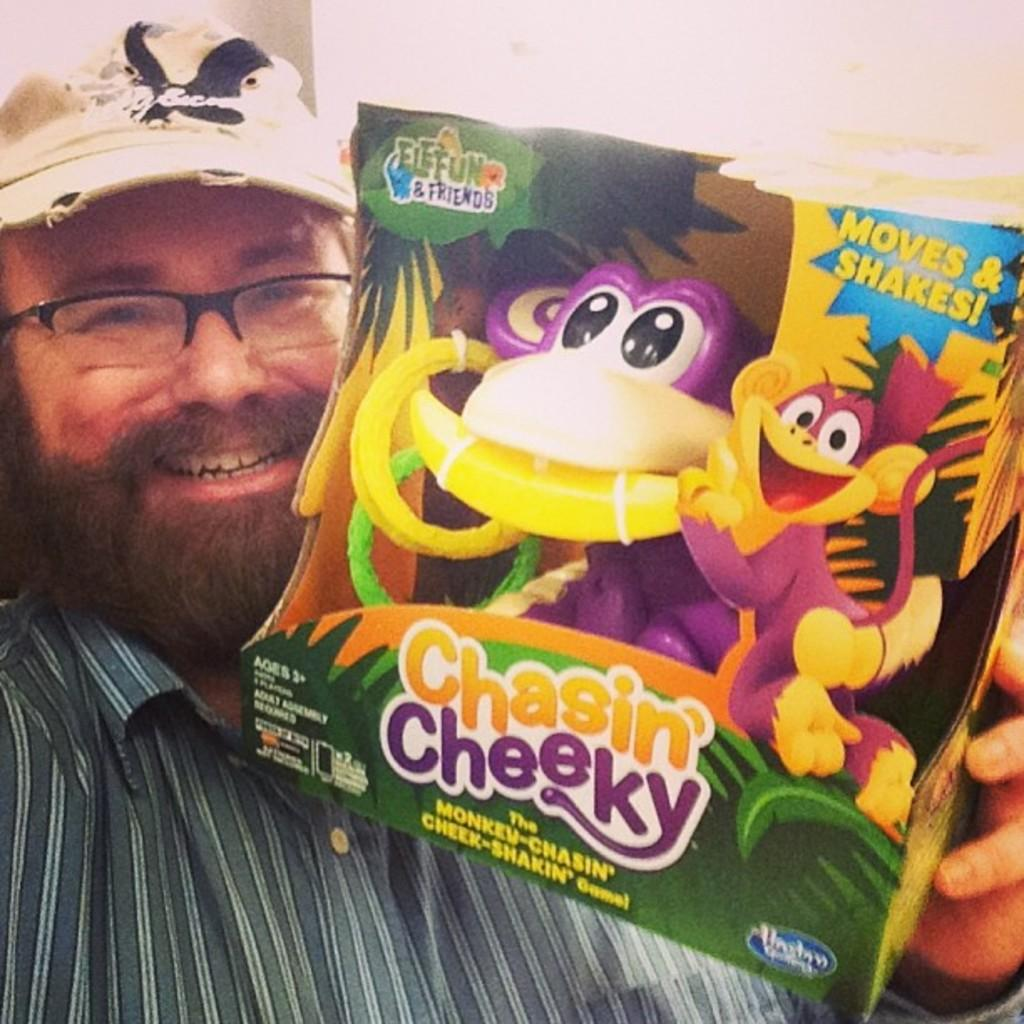What is the main subject of the image? There is a person in the image. What is the person holding in his hand? The person is holding a gem box in his hand. How does the person appear to be feeling in the image? The person has a smile on his face, which suggests he is happy or content. What type of bird is sitting on the queen's shoulder in the image? There is no queen or bird present in the image; it features a person holding a gem box and smiling. 